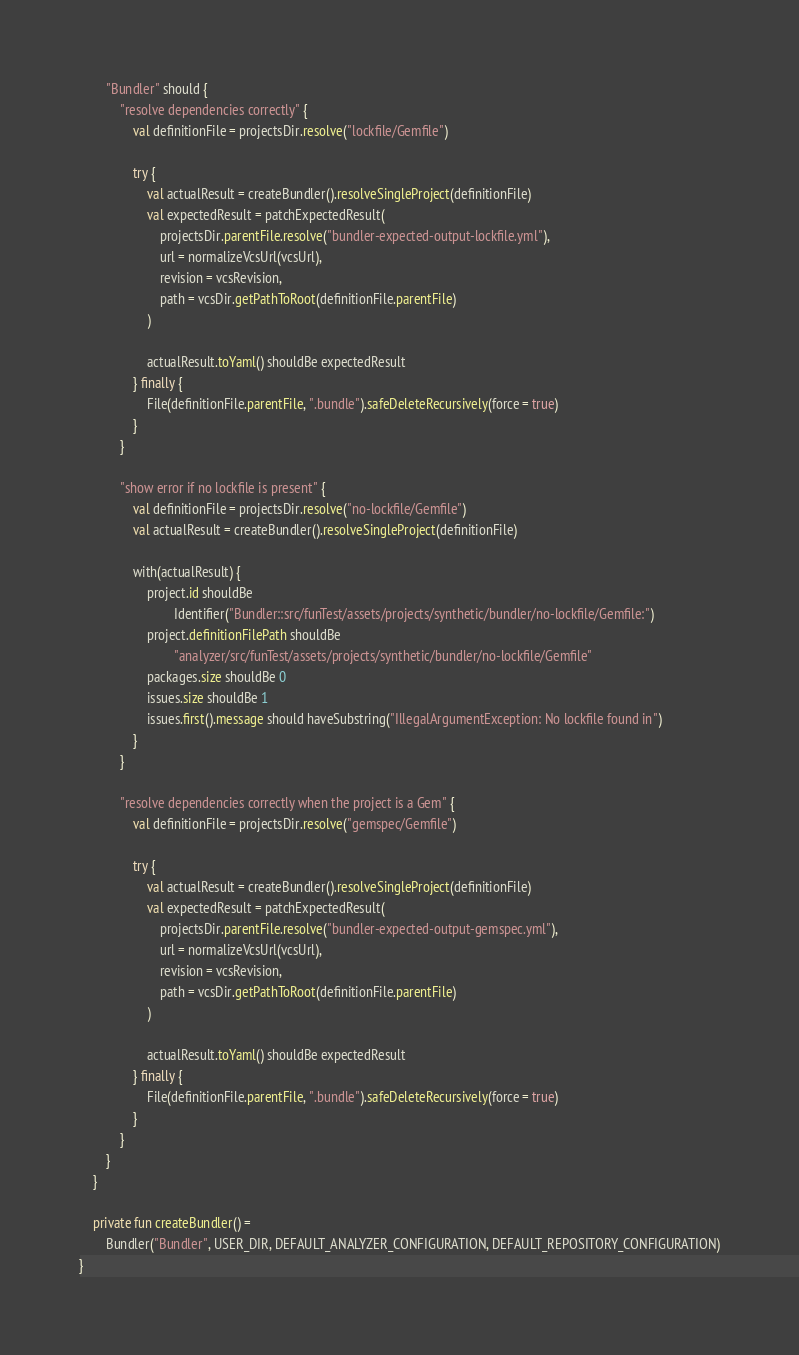Convert code to text. <code><loc_0><loc_0><loc_500><loc_500><_Kotlin_>        "Bundler" should {
            "resolve dependencies correctly" {
                val definitionFile = projectsDir.resolve("lockfile/Gemfile")

                try {
                    val actualResult = createBundler().resolveSingleProject(definitionFile)
                    val expectedResult = patchExpectedResult(
                        projectsDir.parentFile.resolve("bundler-expected-output-lockfile.yml"),
                        url = normalizeVcsUrl(vcsUrl),
                        revision = vcsRevision,
                        path = vcsDir.getPathToRoot(definitionFile.parentFile)
                    )

                    actualResult.toYaml() shouldBe expectedResult
                } finally {
                    File(definitionFile.parentFile, ".bundle").safeDeleteRecursively(force = true)
                }
            }

            "show error if no lockfile is present" {
                val definitionFile = projectsDir.resolve("no-lockfile/Gemfile")
                val actualResult = createBundler().resolveSingleProject(definitionFile)

                with(actualResult) {
                    project.id shouldBe
                            Identifier("Bundler::src/funTest/assets/projects/synthetic/bundler/no-lockfile/Gemfile:")
                    project.definitionFilePath shouldBe
                            "analyzer/src/funTest/assets/projects/synthetic/bundler/no-lockfile/Gemfile"
                    packages.size shouldBe 0
                    issues.size shouldBe 1
                    issues.first().message should haveSubstring("IllegalArgumentException: No lockfile found in")
                }
            }

            "resolve dependencies correctly when the project is a Gem" {
                val definitionFile = projectsDir.resolve("gemspec/Gemfile")

                try {
                    val actualResult = createBundler().resolveSingleProject(definitionFile)
                    val expectedResult = patchExpectedResult(
                        projectsDir.parentFile.resolve("bundler-expected-output-gemspec.yml"),
                        url = normalizeVcsUrl(vcsUrl),
                        revision = vcsRevision,
                        path = vcsDir.getPathToRoot(definitionFile.parentFile)
                    )

                    actualResult.toYaml() shouldBe expectedResult
                } finally {
                    File(definitionFile.parentFile, ".bundle").safeDeleteRecursively(force = true)
                }
            }
        }
    }

    private fun createBundler() =
        Bundler("Bundler", USER_DIR, DEFAULT_ANALYZER_CONFIGURATION, DEFAULT_REPOSITORY_CONFIGURATION)
}
</code> 